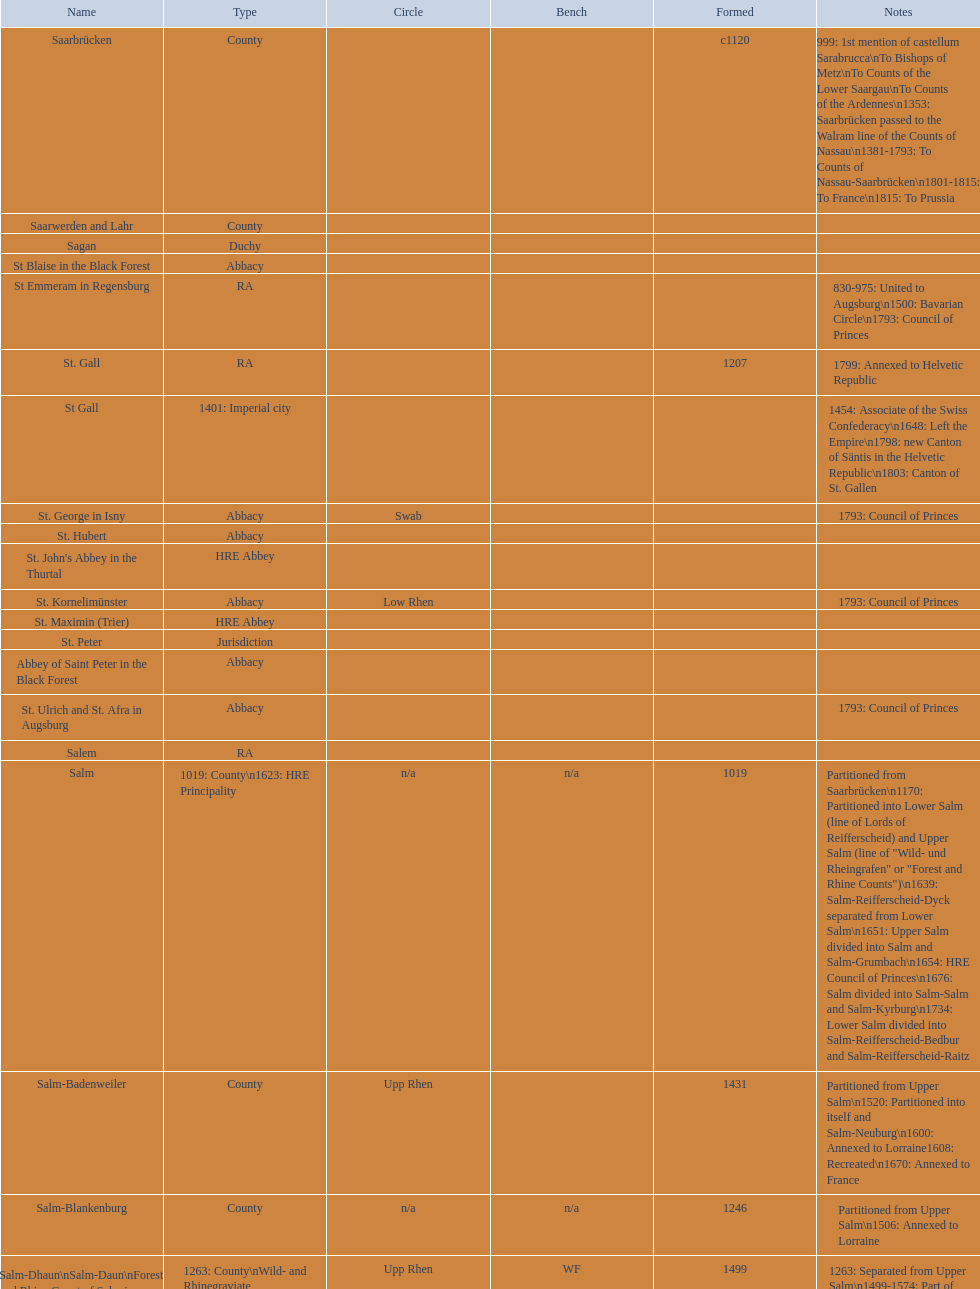Which seat is depicted the most? PR. 